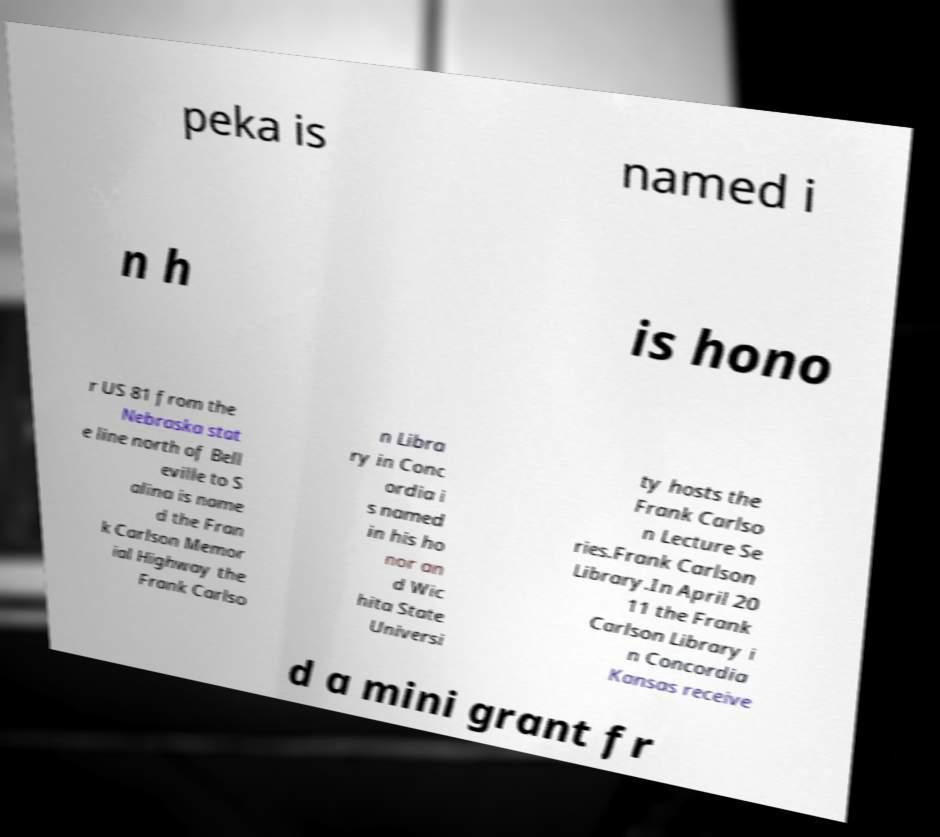Could you assist in decoding the text presented in this image and type it out clearly? peka is named i n h is hono r US 81 from the Nebraska stat e line north of Bell eville to S alina is name d the Fran k Carlson Memor ial Highway the Frank Carlso n Libra ry in Conc ordia i s named in his ho nor an d Wic hita State Universi ty hosts the Frank Carlso n Lecture Se ries.Frank Carlson Library.In April 20 11 the Frank Carlson Library i n Concordia Kansas receive d a mini grant fr 